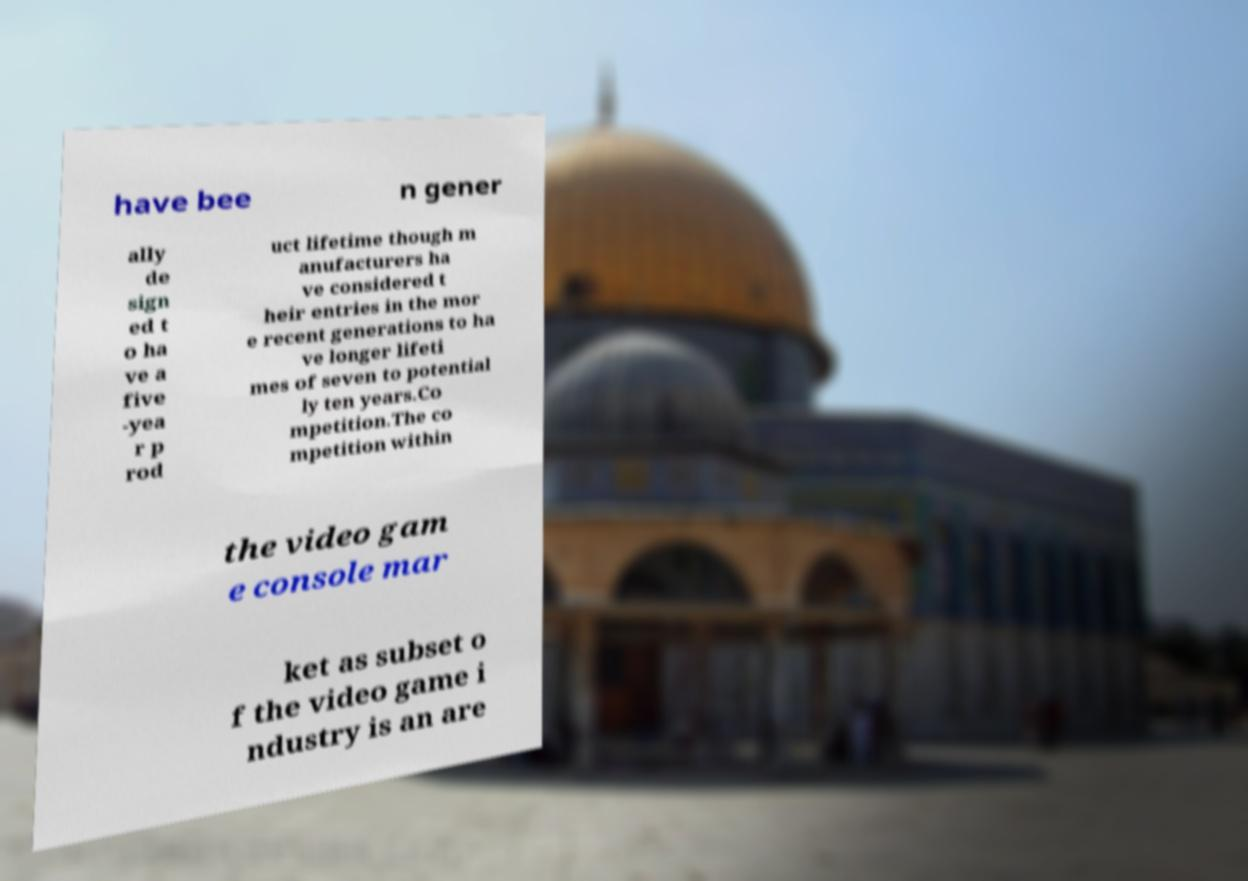What messages or text are displayed in this image? I need them in a readable, typed format. have bee n gener ally de sign ed t o ha ve a five -yea r p rod uct lifetime though m anufacturers ha ve considered t heir entries in the mor e recent generations to ha ve longer lifeti mes of seven to potential ly ten years.Co mpetition.The co mpetition within the video gam e console mar ket as subset o f the video game i ndustry is an are 